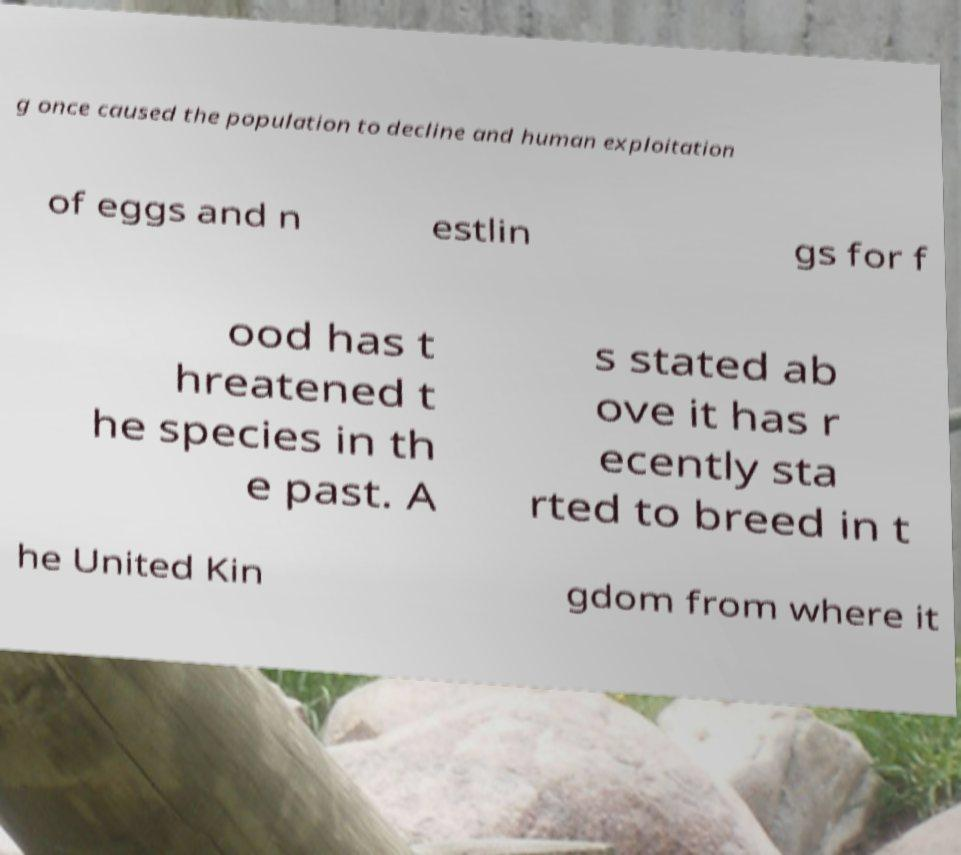There's text embedded in this image that I need extracted. Can you transcribe it verbatim? g once caused the population to decline and human exploitation of eggs and n estlin gs for f ood has t hreatened t he species in th e past. A s stated ab ove it has r ecently sta rted to breed in t he United Kin gdom from where it 